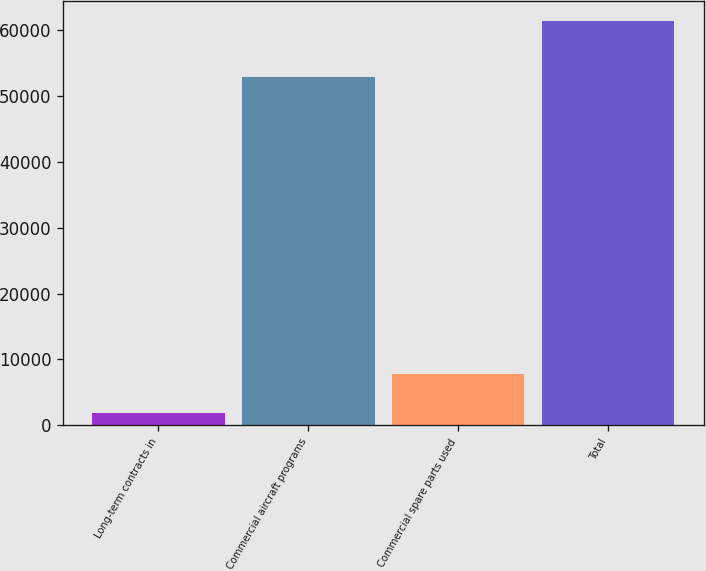Convert chart to OTSL. <chart><loc_0><loc_0><loc_500><loc_500><bar_chart><fcel>Long-term contracts in<fcel>Commercial aircraft programs<fcel>Commercial spare parts used<fcel>Total<nl><fcel>1854<fcel>52861<fcel>7807.4<fcel>61388<nl></chart> 